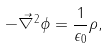<formula> <loc_0><loc_0><loc_500><loc_500>- \vec { \nabla } ^ { 2 } \phi = \frac { 1 } { \epsilon _ { 0 } } \rho ,</formula> 